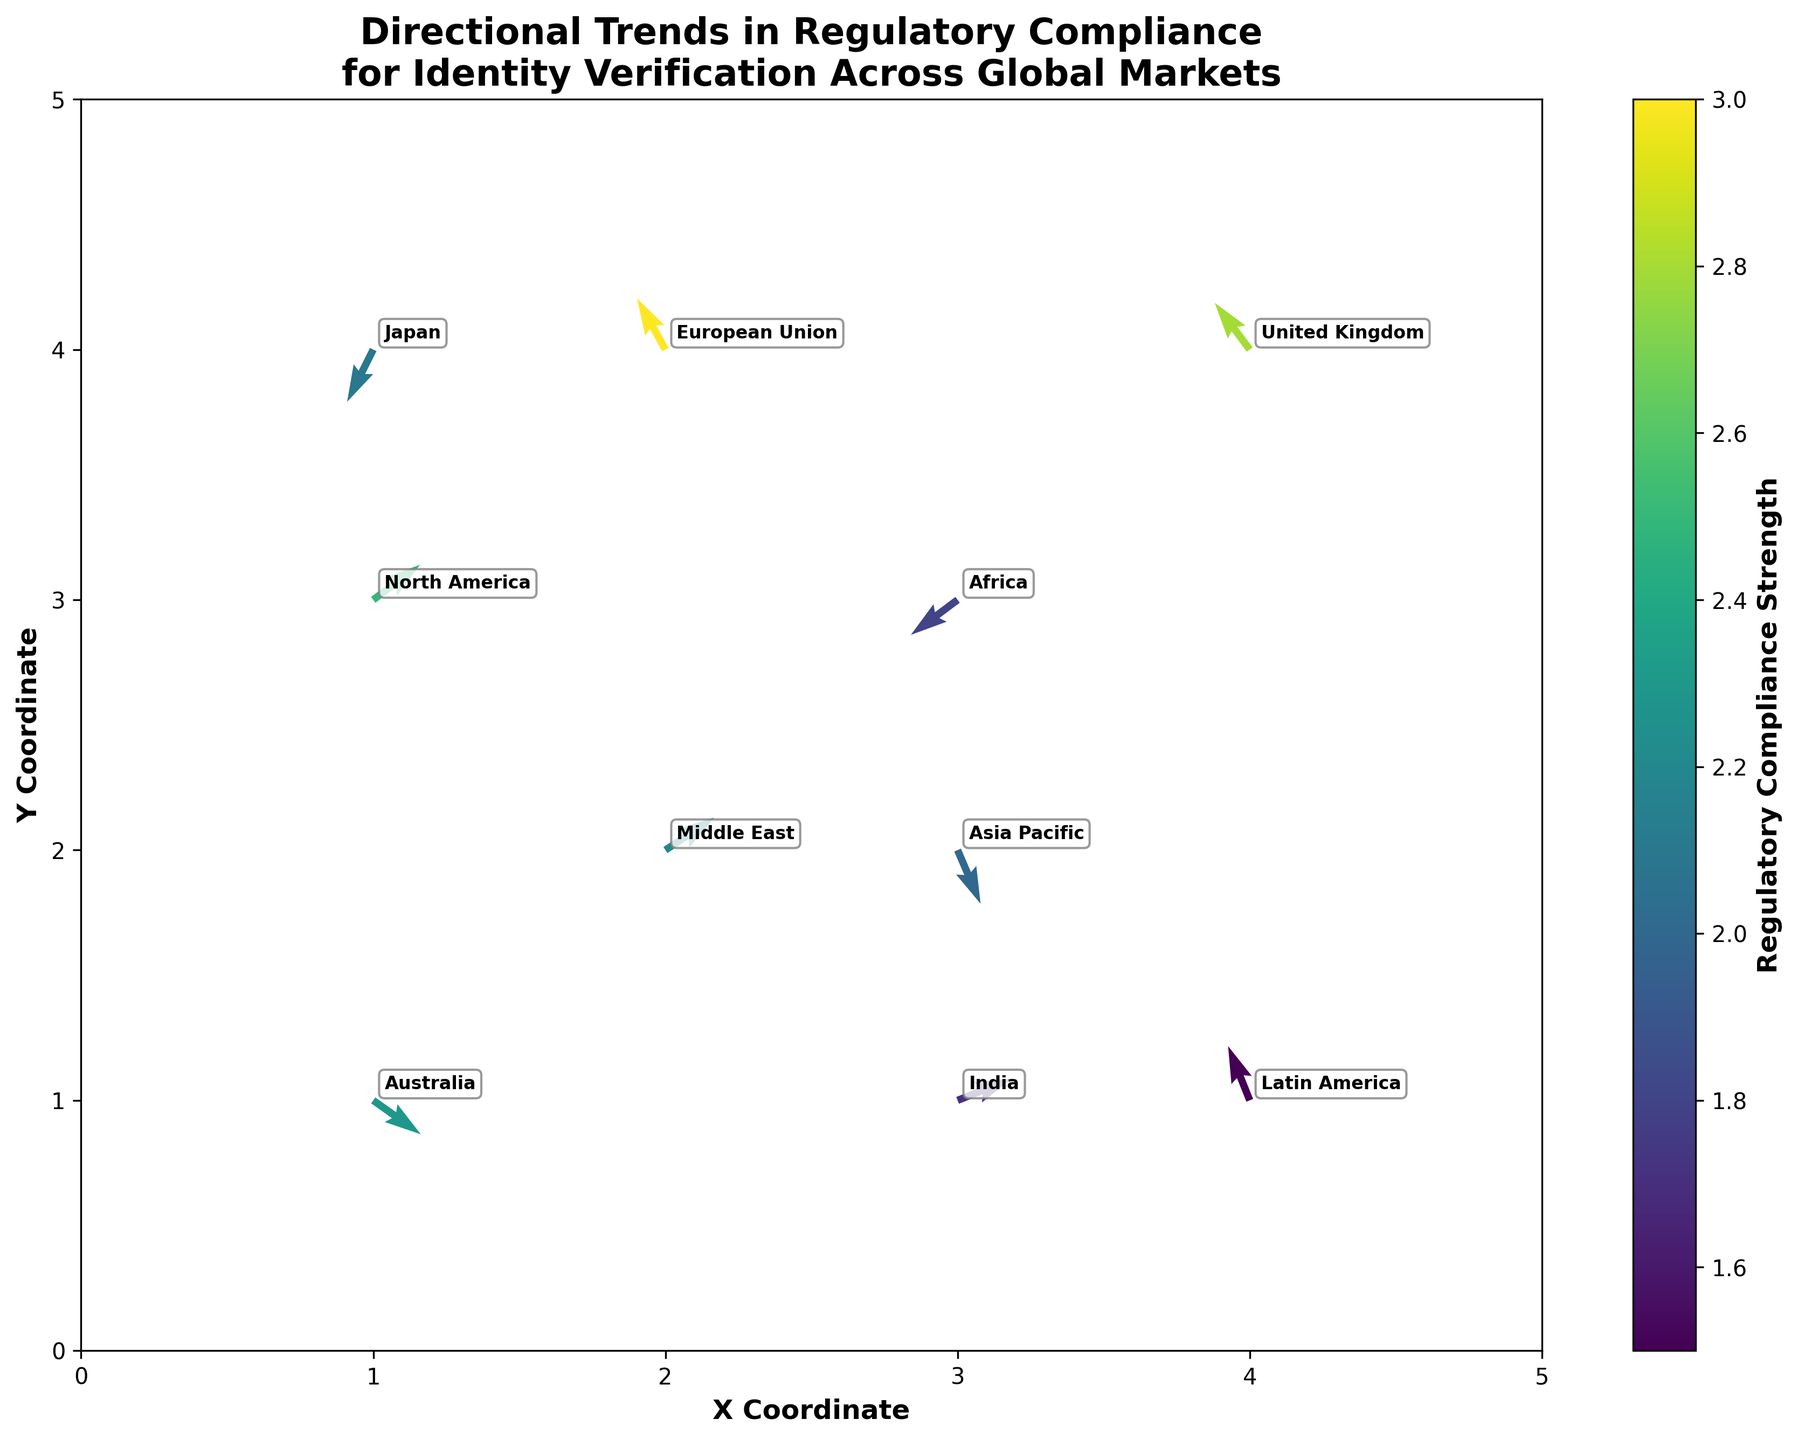How many regions are represented in the figure? To find the number of represented regions, count each labeled data point in the quiver plot. Each label corresponds to a region, and there are 10 labels visible for different regions.
Answer: 10 What does the color represent in the plot? The color of the arrows in the quiver plot represents the strength of regulatory compliance, as indicated by the color bar labeled 'Regulatory Compliance Strength' on the right side of the graph.
Answer: Regulatory compliance strength Which region has the strongest regulatory compliance requirement? Look for the region associated with the darkest arrow, according to the color bar. The European Union has the darkest shade, indicating the strongest regulatory compliance.
Answer: European Union Which regions have arrows that point towards the positive X direction? Identify the arrows pointing rightwards (positive X direction). The regions are North America, Middle East, and India.
Answer: North America, Middle East, India What is the direction of the arrow for Japan? Observe the orientation of the arrow for Japan; it points to the left and downward, representing negative X and negative Y directions respectively.
Answer: Left and downward Does Latin America have a positive or negative U component for its direction? The U component is the X direction of the arrow. For Latin America, the U component is -0.2, which is negative.
Answer: Negative Which regions have arrows pointing predominantly upwards (positive Y direction)? Check for arrows that primarily point upwards (positive Y direction). The regions with such arrows are North America, European Union, Latin America, and the United Kingdom.
Answer: North America, European Union, Latin America, United Kingdom How does the direction of Africa’s regulatory compliance arrow compare to that of Australia? Compare the orientations of the arrows for Africa and Australia. Africa's arrow points left and down, while Australia's arrow points right and down. Both indicate significant differences in direction.
Answer: Different directions In which quadrant is the United Kingdom located? To determine the quadrant, look at the plot's (X,Y) coordinates. The United Kingdom is at (4,4), which is in the first quadrant (both X and Y are positive).
Answer: First quadrant (top-right) What is the average strength of regulatory compliance for the regions plotted? To find the average, add the strengths and divide by the number of regions. Sum strengths: 2.5 + 3.0 + 2.0 + 1.5 + 2.2 + 1.8 + 2.3 + 2.8 + 1.7 + 2.1 = 21.9; then 21.9/10 = 2.19.
Answer: 2.19 